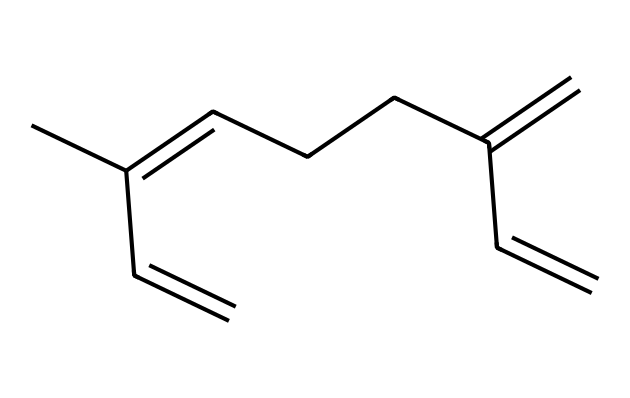What is the name of this chemical? The provided SMILES structure corresponds to myrcene, a common terpene found in mangoes and several other fruits. The name can be derived directly from knowledge of the structure.
Answer: myrcene How many carbon atoms are in this molecule? Counting the carbon atoms in the SMILES representation, we find there are 10 carbon atoms present in the chain of myrcene.
Answer: 10 How many double bonds does myrcene have? By analyzing the chemical structure, we see there are three double bonds in the myrcene structure, indicated by the '=' signs in the SMILES notation.
Answer: 3 Is myrcene more likely to be hydrophilic or hydrophobic? Given that myrcene is a terpene with long hydrocarbon chains and multiple carbon atoms, it is primarily hydrophobic rather than hydrophilic. This is typical for many terpenes.
Answer: hydrophobic What type of chemical is myrcene categorized as? Myrcene belongs to the class of organic compounds known as terpenes, which are characterized by their multiple isoprene units. This structure reflects the typical pathway of terpene formation.
Answer: terpene What is the significance of the double bonds in myrcene? The double bonds in myrcene contribute to its reactivity and influence its aroma and flavor profile, common characteristics of many terpenes. The unsaturation allows for further reactions and alterations in properties.
Answer: reactivity 